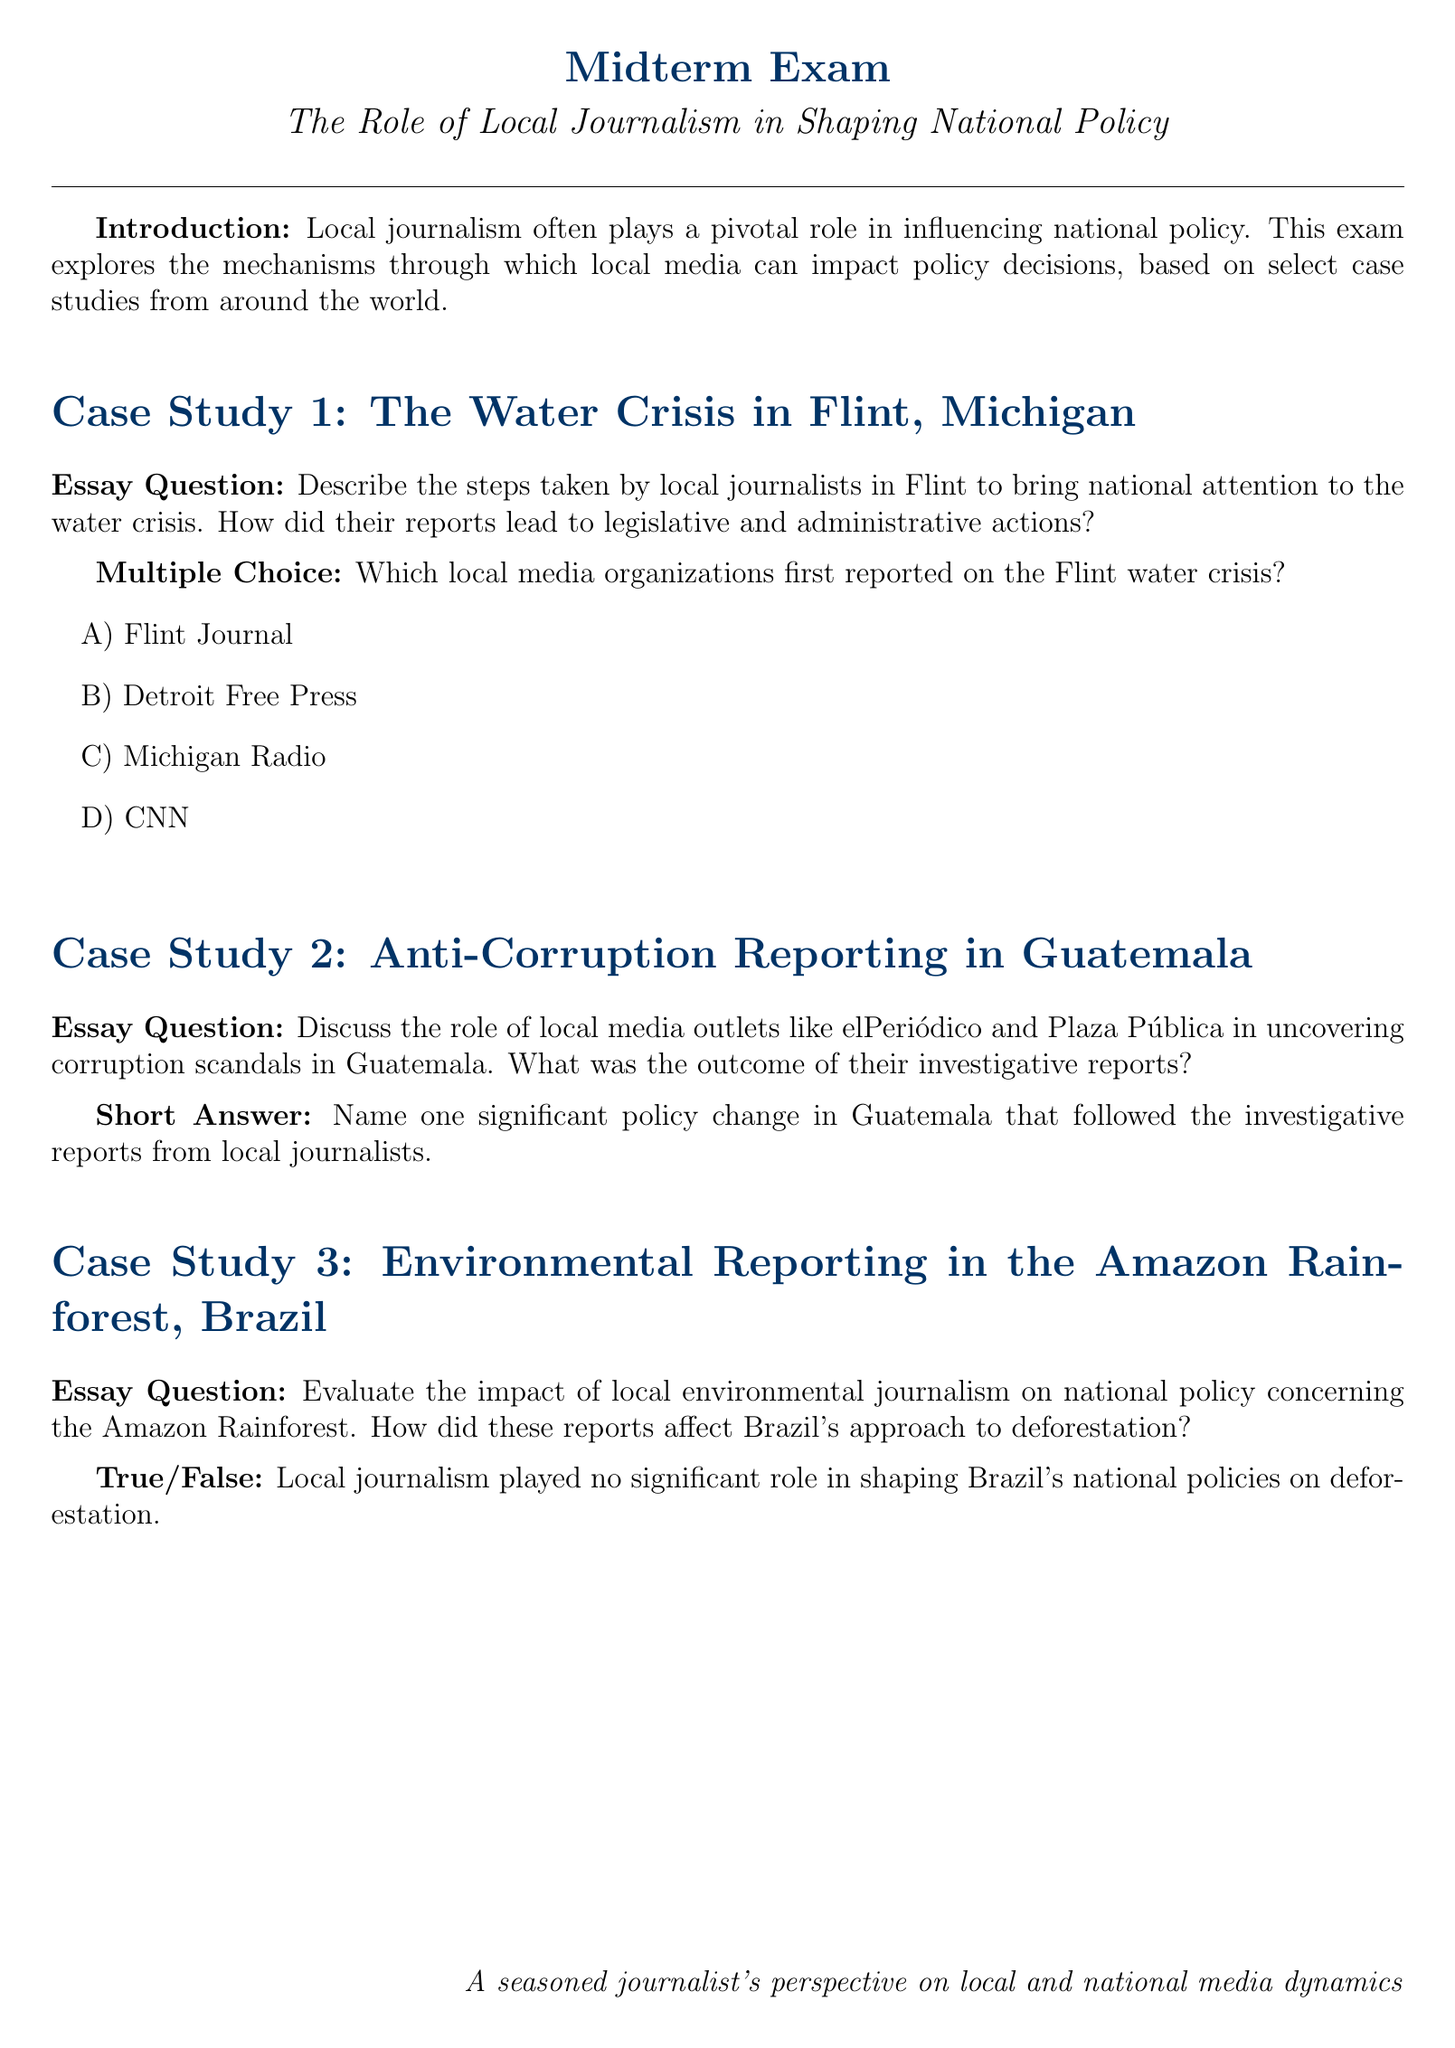What is the main topic of the midterm exam? The main topic of the midterm exam is the role of local journalism in shaping national policy.
Answer: The role of local journalism in shaping national policy Which case study focuses on Flint, Michigan? The first case study in the document specifically addresses the water crisis in Flint, Michigan.
Answer: The Water Crisis in Flint, Michigan What is the format of the first essay question? The first essay question asks about the steps taken by local journalists in Flint to bring national attention to the water crisis.
Answer: Describe the steps taken by local journalists in Flint to bring national attention to the water crisis Which local media organization is mentioned in the multiple-choice question about the Flint water crisis? The Flint Journal is one of the local media organizations listed in the multiple-choice question.
Answer: Flint Journal What investigative role did elPeriódico play in Guatemala? elPeriódico uncovered corruption scandals in Guatemala according to the document.
Answer: Uncovered corruption scandals What type of reporting does the third case study focus on in Brazil? The third case study revolves around environmental reporting related to the Amazon Rainforest.
Answer: Environmental reporting How is the impact of local journalism on Brazil's national policy summarized in the True/False question? The True/False question summarizes that local journalism played no significant role in shaping Brazil's policies on deforestation.
Answer: Local journalism played no significant role What is the significance of the outcome of elPeriódico's reports in Guatemala? The reports led to significant policy changes in Guatemala.
Answer: Significant policy change What does the document suggest about the relationship between local journalism and national policy? The document suggests that local journalism often plays a pivotal role in influencing national policy.
Answer: Pivotal role in influencing national policy 